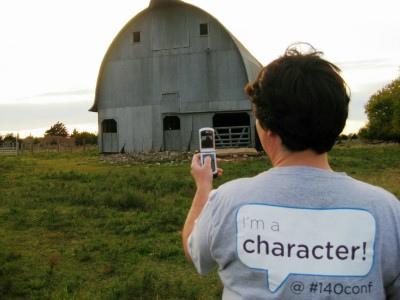Is he taking a photo of a barn?
Answer briefly. Yes. What is this?
Answer briefly. Barn. What is the message on the shirt referencing?
Give a very brief answer. Twitter. 